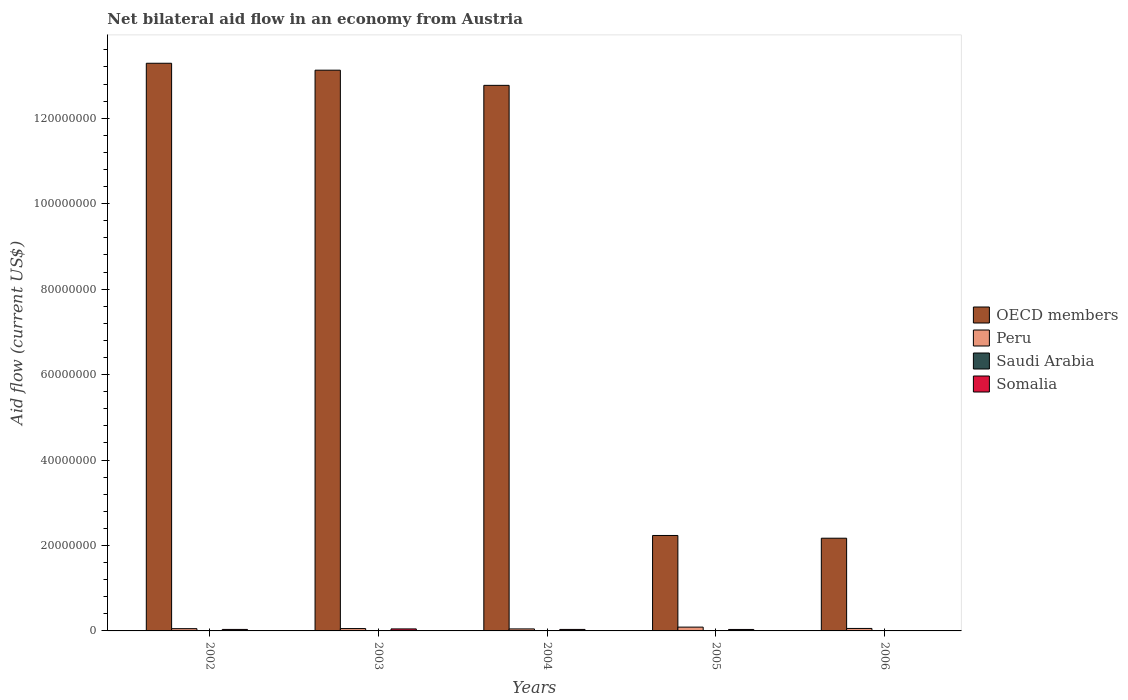Are the number of bars on each tick of the X-axis equal?
Make the answer very short. Yes. How many bars are there on the 1st tick from the left?
Keep it short and to the point. 4. In how many cases, is the number of bars for a given year not equal to the number of legend labels?
Offer a very short reply. 0. What is the net bilateral aid flow in OECD members in 2003?
Provide a succinct answer. 1.31e+08. Across all years, what is the minimum net bilateral aid flow in OECD members?
Offer a terse response. 2.17e+07. In which year was the net bilateral aid flow in OECD members maximum?
Offer a terse response. 2002. In which year was the net bilateral aid flow in Somalia minimum?
Offer a very short reply. 2006. What is the total net bilateral aid flow in Peru in the graph?
Provide a succinct answer. 3.02e+06. What is the difference between the net bilateral aid flow in Saudi Arabia in 2002 and that in 2006?
Make the answer very short. 2.00e+04. What is the difference between the net bilateral aid flow in OECD members in 2005 and the net bilateral aid flow in Peru in 2003?
Offer a very short reply. 2.18e+07. What is the average net bilateral aid flow in Somalia per year?
Ensure brevity in your answer.  3.06e+05. In the year 2002, what is the difference between the net bilateral aid flow in Peru and net bilateral aid flow in OECD members?
Make the answer very short. -1.32e+08. In how many years, is the net bilateral aid flow in Peru greater than 112000000 US$?
Provide a succinct answer. 0. What is the ratio of the net bilateral aid flow in OECD members in 2004 to that in 2006?
Offer a very short reply. 5.88. Is the net bilateral aid flow in Saudi Arabia in 2003 less than that in 2006?
Make the answer very short. No. Is the difference between the net bilateral aid flow in Peru in 2002 and 2006 greater than the difference between the net bilateral aid flow in OECD members in 2002 and 2006?
Provide a succinct answer. No. What is the difference between the highest and the second highest net bilateral aid flow in OECD members?
Ensure brevity in your answer.  1.62e+06. What is the difference between the highest and the lowest net bilateral aid flow in OECD members?
Provide a short and direct response. 1.11e+08. What does the 1st bar from the right in 2005 represents?
Provide a succinct answer. Somalia. Is it the case that in every year, the sum of the net bilateral aid flow in Saudi Arabia and net bilateral aid flow in Somalia is greater than the net bilateral aid flow in OECD members?
Make the answer very short. No. How many bars are there?
Ensure brevity in your answer.  20. Are all the bars in the graph horizontal?
Offer a very short reply. No. How many years are there in the graph?
Your response must be concise. 5. Are the values on the major ticks of Y-axis written in scientific E-notation?
Keep it short and to the point. No. Does the graph contain grids?
Keep it short and to the point. No. Where does the legend appear in the graph?
Make the answer very short. Center right. How many legend labels are there?
Your answer should be compact. 4. How are the legend labels stacked?
Your response must be concise. Vertical. What is the title of the graph?
Provide a short and direct response. Net bilateral aid flow in an economy from Austria. What is the label or title of the X-axis?
Provide a succinct answer. Years. What is the label or title of the Y-axis?
Provide a succinct answer. Aid flow (current US$). What is the Aid flow (current US$) in OECD members in 2002?
Your answer should be very brief. 1.33e+08. What is the Aid flow (current US$) in Peru in 2002?
Make the answer very short. 5.30e+05. What is the Aid flow (current US$) of Somalia in 2002?
Make the answer very short. 3.50e+05. What is the Aid flow (current US$) in OECD members in 2003?
Give a very brief answer. 1.31e+08. What is the Aid flow (current US$) of OECD members in 2004?
Provide a succinct answer. 1.28e+08. What is the Aid flow (current US$) of Peru in 2004?
Your response must be concise. 4.70e+05. What is the Aid flow (current US$) in Somalia in 2004?
Provide a succinct answer. 3.50e+05. What is the Aid flow (current US$) in OECD members in 2005?
Provide a short and direct response. 2.23e+07. What is the Aid flow (current US$) of Peru in 2005?
Offer a very short reply. 8.90e+05. What is the Aid flow (current US$) of Somalia in 2005?
Give a very brief answer. 3.40e+05. What is the Aid flow (current US$) in OECD members in 2006?
Offer a terse response. 2.17e+07. What is the Aid flow (current US$) of Peru in 2006?
Offer a very short reply. 5.80e+05. What is the Aid flow (current US$) of Saudi Arabia in 2006?
Your answer should be compact. 3.00e+04. What is the Aid flow (current US$) in Somalia in 2006?
Ensure brevity in your answer.  2.00e+04. Across all years, what is the maximum Aid flow (current US$) in OECD members?
Keep it short and to the point. 1.33e+08. Across all years, what is the maximum Aid flow (current US$) in Peru?
Your answer should be compact. 8.90e+05. Across all years, what is the maximum Aid flow (current US$) of Saudi Arabia?
Provide a short and direct response. 9.00e+04. Across all years, what is the minimum Aid flow (current US$) in OECD members?
Provide a short and direct response. 2.17e+07. Across all years, what is the minimum Aid flow (current US$) of Saudi Arabia?
Keep it short and to the point. 3.00e+04. What is the total Aid flow (current US$) of OECD members in the graph?
Give a very brief answer. 4.36e+08. What is the total Aid flow (current US$) in Peru in the graph?
Keep it short and to the point. 3.02e+06. What is the total Aid flow (current US$) in Somalia in the graph?
Keep it short and to the point. 1.53e+06. What is the difference between the Aid flow (current US$) of OECD members in 2002 and that in 2003?
Give a very brief answer. 1.62e+06. What is the difference between the Aid flow (current US$) in Saudi Arabia in 2002 and that in 2003?
Provide a succinct answer. -4.00e+04. What is the difference between the Aid flow (current US$) in Somalia in 2002 and that in 2003?
Provide a succinct answer. -1.20e+05. What is the difference between the Aid flow (current US$) in OECD members in 2002 and that in 2004?
Provide a succinct answer. 5.17e+06. What is the difference between the Aid flow (current US$) in Peru in 2002 and that in 2004?
Make the answer very short. 6.00e+04. What is the difference between the Aid flow (current US$) of Somalia in 2002 and that in 2004?
Your answer should be compact. 0. What is the difference between the Aid flow (current US$) in OECD members in 2002 and that in 2005?
Offer a very short reply. 1.11e+08. What is the difference between the Aid flow (current US$) in Peru in 2002 and that in 2005?
Ensure brevity in your answer.  -3.60e+05. What is the difference between the Aid flow (current US$) of OECD members in 2002 and that in 2006?
Your answer should be compact. 1.11e+08. What is the difference between the Aid flow (current US$) of Somalia in 2002 and that in 2006?
Give a very brief answer. 3.30e+05. What is the difference between the Aid flow (current US$) in OECD members in 2003 and that in 2004?
Offer a terse response. 3.55e+06. What is the difference between the Aid flow (current US$) in OECD members in 2003 and that in 2005?
Make the answer very short. 1.09e+08. What is the difference between the Aid flow (current US$) of Somalia in 2003 and that in 2005?
Give a very brief answer. 1.30e+05. What is the difference between the Aid flow (current US$) of OECD members in 2003 and that in 2006?
Provide a succinct answer. 1.10e+08. What is the difference between the Aid flow (current US$) of Peru in 2003 and that in 2006?
Make the answer very short. -3.00e+04. What is the difference between the Aid flow (current US$) of Saudi Arabia in 2003 and that in 2006?
Your response must be concise. 6.00e+04. What is the difference between the Aid flow (current US$) of Somalia in 2003 and that in 2006?
Your answer should be compact. 4.50e+05. What is the difference between the Aid flow (current US$) in OECD members in 2004 and that in 2005?
Make the answer very short. 1.05e+08. What is the difference between the Aid flow (current US$) of Peru in 2004 and that in 2005?
Your response must be concise. -4.20e+05. What is the difference between the Aid flow (current US$) in OECD members in 2004 and that in 2006?
Provide a succinct answer. 1.06e+08. What is the difference between the Aid flow (current US$) in Peru in 2004 and that in 2006?
Offer a very short reply. -1.10e+05. What is the difference between the Aid flow (current US$) in Somalia in 2004 and that in 2006?
Offer a very short reply. 3.30e+05. What is the difference between the Aid flow (current US$) in OECD members in 2005 and that in 2006?
Provide a short and direct response. 6.40e+05. What is the difference between the Aid flow (current US$) of Peru in 2005 and that in 2006?
Give a very brief answer. 3.10e+05. What is the difference between the Aid flow (current US$) in OECD members in 2002 and the Aid flow (current US$) in Peru in 2003?
Ensure brevity in your answer.  1.32e+08. What is the difference between the Aid flow (current US$) of OECD members in 2002 and the Aid flow (current US$) of Saudi Arabia in 2003?
Your response must be concise. 1.33e+08. What is the difference between the Aid flow (current US$) of OECD members in 2002 and the Aid flow (current US$) of Somalia in 2003?
Your answer should be compact. 1.32e+08. What is the difference between the Aid flow (current US$) of Saudi Arabia in 2002 and the Aid flow (current US$) of Somalia in 2003?
Offer a very short reply. -4.20e+05. What is the difference between the Aid flow (current US$) in OECD members in 2002 and the Aid flow (current US$) in Peru in 2004?
Offer a terse response. 1.32e+08. What is the difference between the Aid flow (current US$) of OECD members in 2002 and the Aid flow (current US$) of Saudi Arabia in 2004?
Offer a very short reply. 1.33e+08. What is the difference between the Aid flow (current US$) of OECD members in 2002 and the Aid flow (current US$) of Somalia in 2004?
Your response must be concise. 1.33e+08. What is the difference between the Aid flow (current US$) of Saudi Arabia in 2002 and the Aid flow (current US$) of Somalia in 2004?
Make the answer very short. -3.00e+05. What is the difference between the Aid flow (current US$) in OECD members in 2002 and the Aid flow (current US$) in Peru in 2005?
Offer a terse response. 1.32e+08. What is the difference between the Aid flow (current US$) in OECD members in 2002 and the Aid flow (current US$) in Saudi Arabia in 2005?
Keep it short and to the point. 1.33e+08. What is the difference between the Aid flow (current US$) of OECD members in 2002 and the Aid flow (current US$) of Somalia in 2005?
Keep it short and to the point. 1.33e+08. What is the difference between the Aid flow (current US$) of Peru in 2002 and the Aid flow (current US$) of Saudi Arabia in 2005?
Offer a terse response. 4.90e+05. What is the difference between the Aid flow (current US$) in OECD members in 2002 and the Aid flow (current US$) in Peru in 2006?
Your answer should be very brief. 1.32e+08. What is the difference between the Aid flow (current US$) of OECD members in 2002 and the Aid flow (current US$) of Saudi Arabia in 2006?
Make the answer very short. 1.33e+08. What is the difference between the Aid flow (current US$) of OECD members in 2002 and the Aid flow (current US$) of Somalia in 2006?
Offer a very short reply. 1.33e+08. What is the difference between the Aid flow (current US$) in Peru in 2002 and the Aid flow (current US$) in Somalia in 2006?
Your answer should be very brief. 5.10e+05. What is the difference between the Aid flow (current US$) in Saudi Arabia in 2002 and the Aid flow (current US$) in Somalia in 2006?
Provide a short and direct response. 3.00e+04. What is the difference between the Aid flow (current US$) in OECD members in 2003 and the Aid flow (current US$) in Peru in 2004?
Make the answer very short. 1.31e+08. What is the difference between the Aid flow (current US$) in OECD members in 2003 and the Aid flow (current US$) in Saudi Arabia in 2004?
Make the answer very short. 1.31e+08. What is the difference between the Aid flow (current US$) of OECD members in 2003 and the Aid flow (current US$) of Somalia in 2004?
Your answer should be compact. 1.31e+08. What is the difference between the Aid flow (current US$) in Peru in 2003 and the Aid flow (current US$) in Saudi Arabia in 2004?
Provide a succinct answer. 5.10e+05. What is the difference between the Aid flow (current US$) of Saudi Arabia in 2003 and the Aid flow (current US$) of Somalia in 2004?
Ensure brevity in your answer.  -2.60e+05. What is the difference between the Aid flow (current US$) of OECD members in 2003 and the Aid flow (current US$) of Peru in 2005?
Give a very brief answer. 1.30e+08. What is the difference between the Aid flow (current US$) in OECD members in 2003 and the Aid flow (current US$) in Saudi Arabia in 2005?
Offer a terse response. 1.31e+08. What is the difference between the Aid flow (current US$) of OECD members in 2003 and the Aid flow (current US$) of Somalia in 2005?
Give a very brief answer. 1.31e+08. What is the difference between the Aid flow (current US$) in Peru in 2003 and the Aid flow (current US$) in Saudi Arabia in 2005?
Give a very brief answer. 5.10e+05. What is the difference between the Aid flow (current US$) of Saudi Arabia in 2003 and the Aid flow (current US$) of Somalia in 2005?
Offer a very short reply. -2.50e+05. What is the difference between the Aid flow (current US$) in OECD members in 2003 and the Aid flow (current US$) in Peru in 2006?
Give a very brief answer. 1.31e+08. What is the difference between the Aid flow (current US$) in OECD members in 2003 and the Aid flow (current US$) in Saudi Arabia in 2006?
Keep it short and to the point. 1.31e+08. What is the difference between the Aid flow (current US$) in OECD members in 2003 and the Aid flow (current US$) in Somalia in 2006?
Make the answer very short. 1.31e+08. What is the difference between the Aid flow (current US$) in Peru in 2003 and the Aid flow (current US$) in Saudi Arabia in 2006?
Ensure brevity in your answer.  5.20e+05. What is the difference between the Aid flow (current US$) in Peru in 2003 and the Aid flow (current US$) in Somalia in 2006?
Your answer should be compact. 5.30e+05. What is the difference between the Aid flow (current US$) in Saudi Arabia in 2003 and the Aid flow (current US$) in Somalia in 2006?
Your answer should be compact. 7.00e+04. What is the difference between the Aid flow (current US$) of OECD members in 2004 and the Aid flow (current US$) of Peru in 2005?
Provide a short and direct response. 1.27e+08. What is the difference between the Aid flow (current US$) in OECD members in 2004 and the Aid flow (current US$) in Saudi Arabia in 2005?
Give a very brief answer. 1.28e+08. What is the difference between the Aid flow (current US$) of OECD members in 2004 and the Aid flow (current US$) of Somalia in 2005?
Offer a very short reply. 1.27e+08. What is the difference between the Aid flow (current US$) of Peru in 2004 and the Aid flow (current US$) of Saudi Arabia in 2005?
Your answer should be compact. 4.30e+05. What is the difference between the Aid flow (current US$) of Saudi Arabia in 2004 and the Aid flow (current US$) of Somalia in 2005?
Provide a succinct answer. -3.00e+05. What is the difference between the Aid flow (current US$) of OECD members in 2004 and the Aid flow (current US$) of Peru in 2006?
Give a very brief answer. 1.27e+08. What is the difference between the Aid flow (current US$) of OECD members in 2004 and the Aid flow (current US$) of Saudi Arabia in 2006?
Offer a very short reply. 1.28e+08. What is the difference between the Aid flow (current US$) of OECD members in 2004 and the Aid flow (current US$) of Somalia in 2006?
Give a very brief answer. 1.28e+08. What is the difference between the Aid flow (current US$) of OECD members in 2005 and the Aid flow (current US$) of Peru in 2006?
Provide a succinct answer. 2.18e+07. What is the difference between the Aid flow (current US$) in OECD members in 2005 and the Aid flow (current US$) in Saudi Arabia in 2006?
Provide a succinct answer. 2.23e+07. What is the difference between the Aid flow (current US$) in OECD members in 2005 and the Aid flow (current US$) in Somalia in 2006?
Make the answer very short. 2.23e+07. What is the difference between the Aid flow (current US$) of Peru in 2005 and the Aid flow (current US$) of Saudi Arabia in 2006?
Your response must be concise. 8.60e+05. What is the difference between the Aid flow (current US$) of Peru in 2005 and the Aid flow (current US$) of Somalia in 2006?
Offer a terse response. 8.70e+05. What is the average Aid flow (current US$) in OECD members per year?
Provide a short and direct response. 8.72e+07. What is the average Aid flow (current US$) of Peru per year?
Provide a succinct answer. 6.04e+05. What is the average Aid flow (current US$) in Saudi Arabia per year?
Give a very brief answer. 5.00e+04. What is the average Aid flow (current US$) of Somalia per year?
Provide a short and direct response. 3.06e+05. In the year 2002, what is the difference between the Aid flow (current US$) in OECD members and Aid flow (current US$) in Peru?
Keep it short and to the point. 1.32e+08. In the year 2002, what is the difference between the Aid flow (current US$) in OECD members and Aid flow (current US$) in Saudi Arabia?
Your answer should be very brief. 1.33e+08. In the year 2002, what is the difference between the Aid flow (current US$) in OECD members and Aid flow (current US$) in Somalia?
Offer a terse response. 1.33e+08. In the year 2002, what is the difference between the Aid flow (current US$) in Peru and Aid flow (current US$) in Saudi Arabia?
Provide a succinct answer. 4.80e+05. In the year 2003, what is the difference between the Aid flow (current US$) in OECD members and Aid flow (current US$) in Peru?
Make the answer very short. 1.31e+08. In the year 2003, what is the difference between the Aid flow (current US$) in OECD members and Aid flow (current US$) in Saudi Arabia?
Your answer should be compact. 1.31e+08. In the year 2003, what is the difference between the Aid flow (current US$) of OECD members and Aid flow (current US$) of Somalia?
Keep it short and to the point. 1.31e+08. In the year 2003, what is the difference between the Aid flow (current US$) of Peru and Aid flow (current US$) of Somalia?
Ensure brevity in your answer.  8.00e+04. In the year 2003, what is the difference between the Aid flow (current US$) of Saudi Arabia and Aid flow (current US$) of Somalia?
Keep it short and to the point. -3.80e+05. In the year 2004, what is the difference between the Aid flow (current US$) of OECD members and Aid flow (current US$) of Peru?
Give a very brief answer. 1.27e+08. In the year 2004, what is the difference between the Aid flow (current US$) in OECD members and Aid flow (current US$) in Saudi Arabia?
Offer a very short reply. 1.28e+08. In the year 2004, what is the difference between the Aid flow (current US$) of OECD members and Aid flow (current US$) of Somalia?
Provide a succinct answer. 1.27e+08. In the year 2004, what is the difference between the Aid flow (current US$) in Peru and Aid flow (current US$) in Saudi Arabia?
Make the answer very short. 4.30e+05. In the year 2004, what is the difference between the Aid flow (current US$) of Saudi Arabia and Aid flow (current US$) of Somalia?
Give a very brief answer. -3.10e+05. In the year 2005, what is the difference between the Aid flow (current US$) in OECD members and Aid flow (current US$) in Peru?
Ensure brevity in your answer.  2.14e+07. In the year 2005, what is the difference between the Aid flow (current US$) in OECD members and Aid flow (current US$) in Saudi Arabia?
Your answer should be compact. 2.23e+07. In the year 2005, what is the difference between the Aid flow (current US$) of OECD members and Aid flow (current US$) of Somalia?
Provide a succinct answer. 2.20e+07. In the year 2005, what is the difference between the Aid flow (current US$) in Peru and Aid flow (current US$) in Saudi Arabia?
Make the answer very short. 8.50e+05. In the year 2005, what is the difference between the Aid flow (current US$) of Peru and Aid flow (current US$) of Somalia?
Your answer should be compact. 5.50e+05. In the year 2005, what is the difference between the Aid flow (current US$) in Saudi Arabia and Aid flow (current US$) in Somalia?
Your answer should be very brief. -3.00e+05. In the year 2006, what is the difference between the Aid flow (current US$) of OECD members and Aid flow (current US$) of Peru?
Your response must be concise. 2.11e+07. In the year 2006, what is the difference between the Aid flow (current US$) of OECD members and Aid flow (current US$) of Saudi Arabia?
Provide a succinct answer. 2.17e+07. In the year 2006, what is the difference between the Aid flow (current US$) in OECD members and Aid flow (current US$) in Somalia?
Give a very brief answer. 2.17e+07. In the year 2006, what is the difference between the Aid flow (current US$) of Peru and Aid flow (current US$) of Saudi Arabia?
Keep it short and to the point. 5.50e+05. In the year 2006, what is the difference between the Aid flow (current US$) of Peru and Aid flow (current US$) of Somalia?
Give a very brief answer. 5.60e+05. What is the ratio of the Aid flow (current US$) in OECD members in 2002 to that in 2003?
Keep it short and to the point. 1.01. What is the ratio of the Aid flow (current US$) of Peru in 2002 to that in 2003?
Your response must be concise. 0.96. What is the ratio of the Aid flow (current US$) of Saudi Arabia in 2002 to that in 2003?
Provide a succinct answer. 0.56. What is the ratio of the Aid flow (current US$) in Somalia in 2002 to that in 2003?
Provide a short and direct response. 0.74. What is the ratio of the Aid flow (current US$) in OECD members in 2002 to that in 2004?
Your answer should be compact. 1.04. What is the ratio of the Aid flow (current US$) of Peru in 2002 to that in 2004?
Offer a terse response. 1.13. What is the ratio of the Aid flow (current US$) of Saudi Arabia in 2002 to that in 2004?
Provide a succinct answer. 1.25. What is the ratio of the Aid flow (current US$) in Somalia in 2002 to that in 2004?
Your response must be concise. 1. What is the ratio of the Aid flow (current US$) of OECD members in 2002 to that in 2005?
Ensure brevity in your answer.  5.95. What is the ratio of the Aid flow (current US$) of Peru in 2002 to that in 2005?
Provide a succinct answer. 0.6. What is the ratio of the Aid flow (current US$) of Somalia in 2002 to that in 2005?
Provide a succinct answer. 1.03. What is the ratio of the Aid flow (current US$) of OECD members in 2002 to that in 2006?
Keep it short and to the point. 6.12. What is the ratio of the Aid flow (current US$) in Peru in 2002 to that in 2006?
Your answer should be compact. 0.91. What is the ratio of the Aid flow (current US$) of Somalia in 2002 to that in 2006?
Offer a terse response. 17.5. What is the ratio of the Aid flow (current US$) of OECD members in 2003 to that in 2004?
Give a very brief answer. 1.03. What is the ratio of the Aid flow (current US$) of Peru in 2003 to that in 2004?
Offer a terse response. 1.17. What is the ratio of the Aid flow (current US$) of Saudi Arabia in 2003 to that in 2004?
Provide a short and direct response. 2.25. What is the ratio of the Aid flow (current US$) in Somalia in 2003 to that in 2004?
Provide a succinct answer. 1.34. What is the ratio of the Aid flow (current US$) of OECD members in 2003 to that in 2005?
Your answer should be compact. 5.87. What is the ratio of the Aid flow (current US$) in Peru in 2003 to that in 2005?
Provide a succinct answer. 0.62. What is the ratio of the Aid flow (current US$) of Saudi Arabia in 2003 to that in 2005?
Provide a succinct answer. 2.25. What is the ratio of the Aid flow (current US$) in Somalia in 2003 to that in 2005?
Provide a short and direct response. 1.38. What is the ratio of the Aid flow (current US$) in OECD members in 2003 to that in 2006?
Offer a terse response. 6.05. What is the ratio of the Aid flow (current US$) of Peru in 2003 to that in 2006?
Offer a very short reply. 0.95. What is the ratio of the Aid flow (current US$) of Saudi Arabia in 2003 to that in 2006?
Your response must be concise. 3. What is the ratio of the Aid flow (current US$) in OECD members in 2004 to that in 2005?
Keep it short and to the point. 5.72. What is the ratio of the Aid flow (current US$) of Peru in 2004 to that in 2005?
Your response must be concise. 0.53. What is the ratio of the Aid flow (current US$) of Saudi Arabia in 2004 to that in 2005?
Provide a short and direct response. 1. What is the ratio of the Aid flow (current US$) in Somalia in 2004 to that in 2005?
Your response must be concise. 1.03. What is the ratio of the Aid flow (current US$) of OECD members in 2004 to that in 2006?
Your response must be concise. 5.88. What is the ratio of the Aid flow (current US$) of Peru in 2004 to that in 2006?
Provide a succinct answer. 0.81. What is the ratio of the Aid flow (current US$) of Saudi Arabia in 2004 to that in 2006?
Offer a terse response. 1.33. What is the ratio of the Aid flow (current US$) of Somalia in 2004 to that in 2006?
Your response must be concise. 17.5. What is the ratio of the Aid flow (current US$) of OECD members in 2005 to that in 2006?
Provide a succinct answer. 1.03. What is the ratio of the Aid flow (current US$) in Peru in 2005 to that in 2006?
Offer a terse response. 1.53. What is the ratio of the Aid flow (current US$) in Saudi Arabia in 2005 to that in 2006?
Offer a very short reply. 1.33. What is the ratio of the Aid flow (current US$) of Somalia in 2005 to that in 2006?
Give a very brief answer. 17. What is the difference between the highest and the second highest Aid flow (current US$) of OECD members?
Your answer should be compact. 1.62e+06. What is the difference between the highest and the second highest Aid flow (current US$) in Peru?
Ensure brevity in your answer.  3.10e+05. What is the difference between the highest and the lowest Aid flow (current US$) of OECD members?
Offer a very short reply. 1.11e+08. What is the difference between the highest and the lowest Aid flow (current US$) in Peru?
Your answer should be compact. 4.20e+05. What is the difference between the highest and the lowest Aid flow (current US$) in Saudi Arabia?
Your answer should be compact. 6.00e+04. 